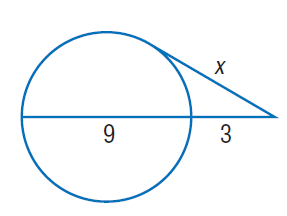Answer the mathemtical geometry problem and directly provide the correct option letter.
Question: Find x. Round to the nearest tenth if necessary. Assume that segments that appear to be tangent are tangent.
Choices: A: 3 B: 6 C: 9 D: 12 B 